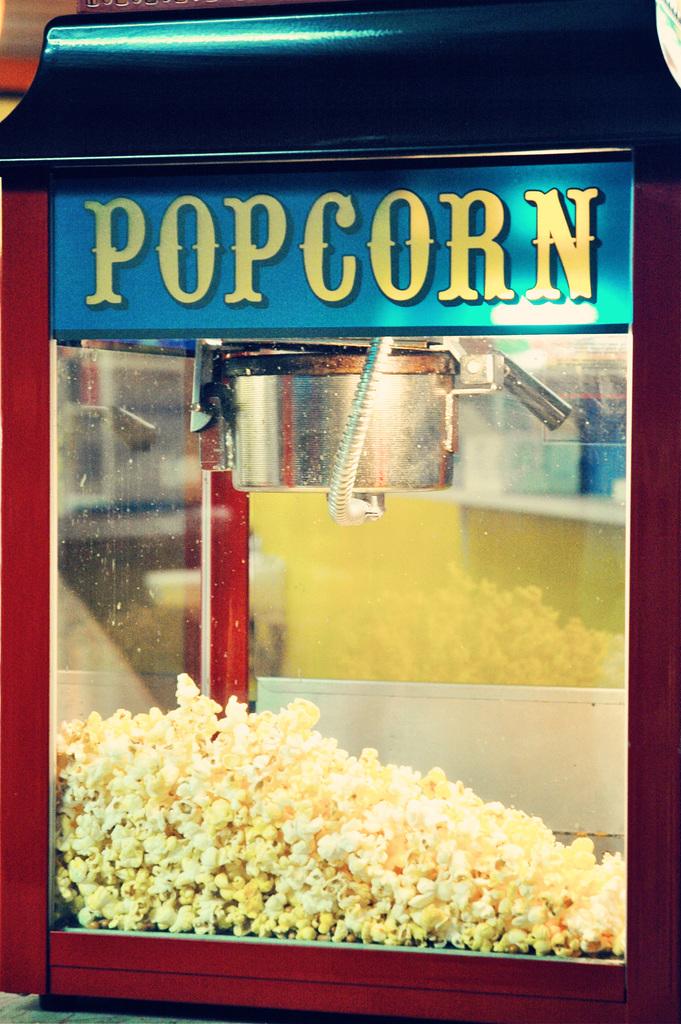What kind of food is in this machine?
Offer a very short reply. Popcorn. What snack is that?
Your answer should be compact. Popcorn. 